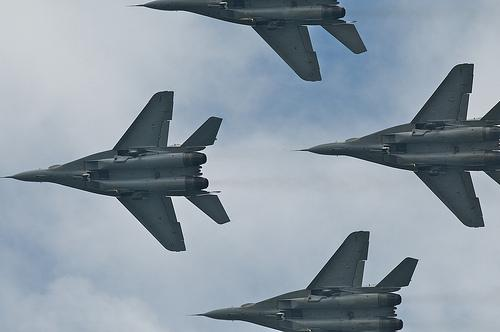Express what the image conveys about the interactions among the objects present. The image portrays a group of jets flying in formation, with one jet following the lead of another, demonstrating their coordination and cooperation. Count the number of engines on the jets and describe their color. There are 8 engines on the jets, and they are gray in color. What is the color of the sky in the image? The sky in the image is blue. What is an interesting aspect of the jet's design that is visible in the image? An interesting aspect of the jet's design visible in the image is the slanted and open rectangular panels. Point out the features of the jets that suggest they are military aircraft. The features of the jets, such as the pointed nose, the presence of multiple engines, and their formation in the sky, suggest that they are military or fighter planes. What can you infer about the airplanes' position and environment from the image? The airplanes are in mid-air, flying against a background of blue sky and white clouds. Mention the main object in the image and provide a brief description of its appearance. The main object in the image is a gray jet flying against a cloudy blue sky, with curved wings and a pointed nose. In a few words, capture the overall sentiment of the image. Dynamic, powerful, and awe-inspiring sky display. Explain the primary focus of the image and its activity. The image predominantly features multiple jets flying across a cloudy blue sky, with one jet following the lead of another. Describe the appearance and shape of the jet's wings and tail. The jet's wings have curved edges, while the tail has a flared geometric shape. 